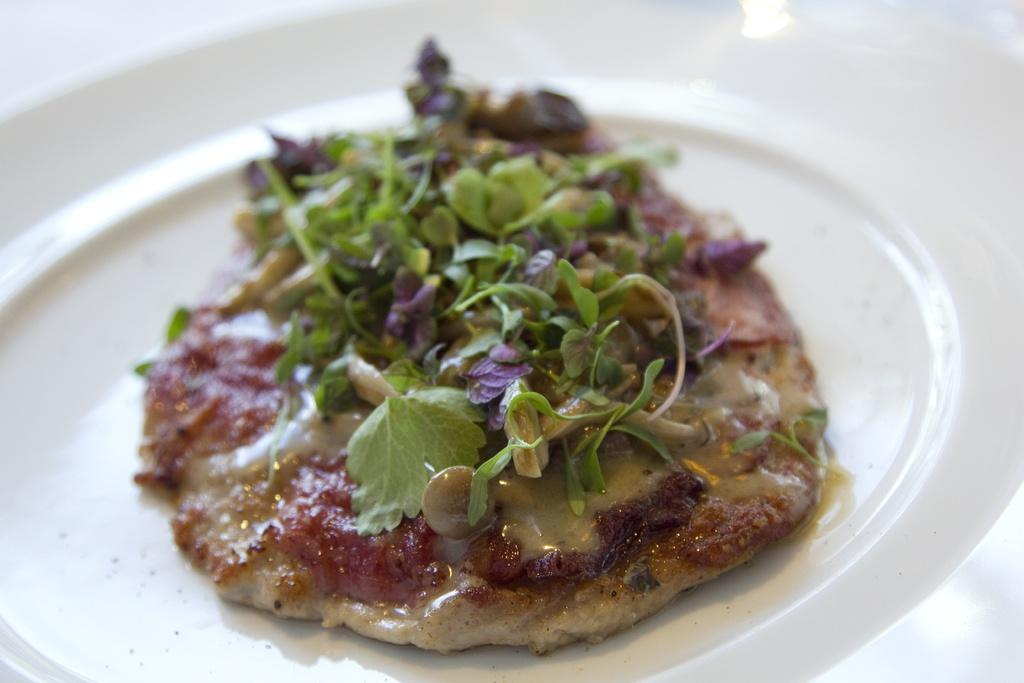What object is present on the plate in the image? There is food on the plate in the image. What can be seen in the background of the image? The background of the image is white in color. How many sheep are visible in the image? There are no sheep present in the image. What type of skin is visible on the food in the image? There is no skin visible on the food in the image. 